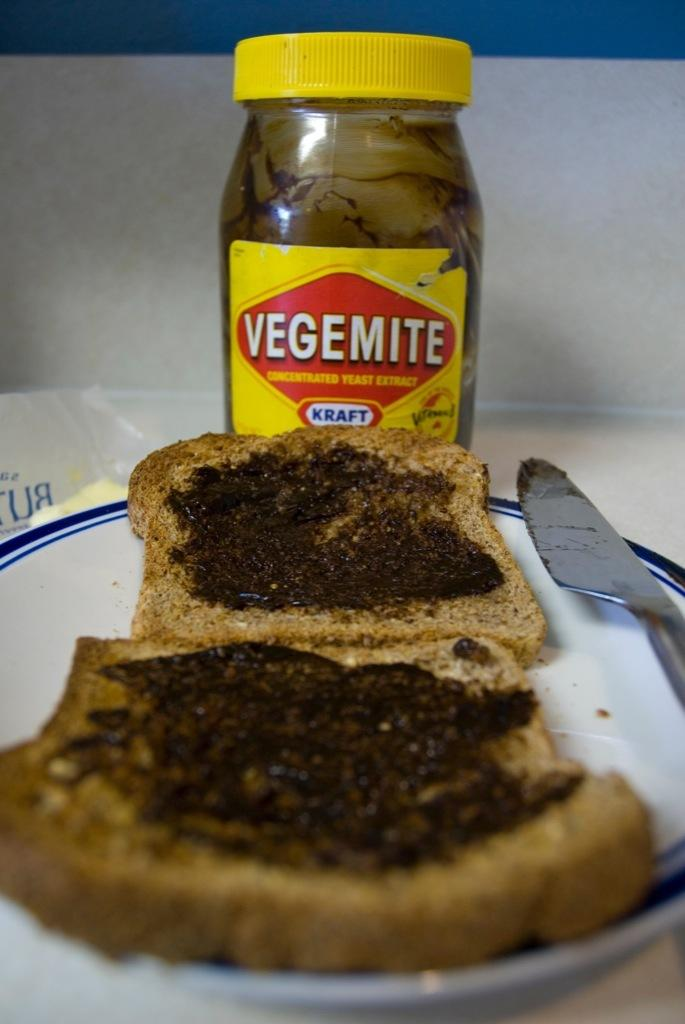What type of food item is visible in the image? There is bread in the image. What utensil is present in the image? There is a knife in the image. Where are the bread and knife located? The bread and knife are on a plate. On what surface is the plate placed? The plate is placed on a table. What other items can be seen in the image? There is a bottle and a cover in the image. How are the bottle and cover positioned in relation to each other? The bottle and cover are beside each other. How many kittens are playing with the credit card in the image? There are no kittens or credit cards present in the image. 